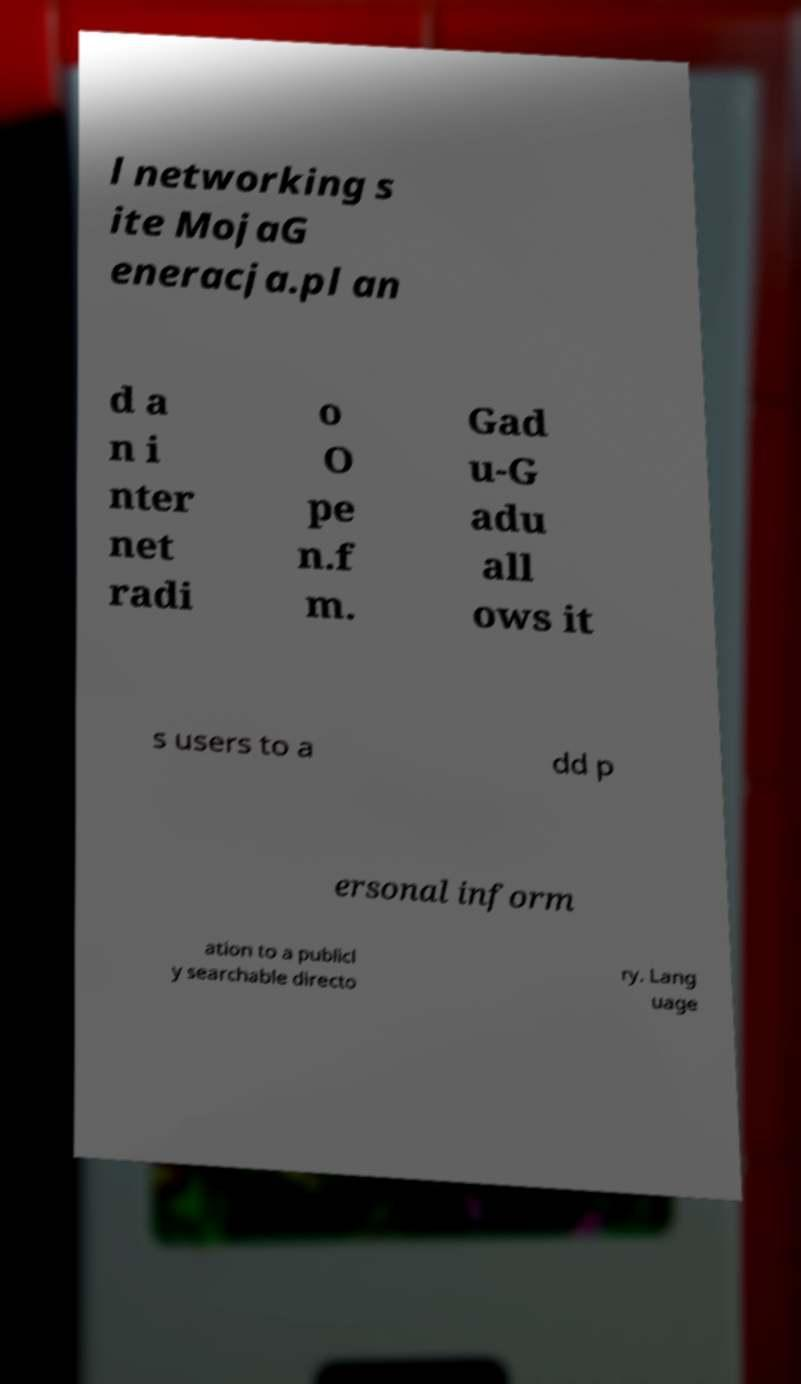Please identify and transcribe the text found in this image. l networking s ite MojaG eneracja.pl an d a n i nter net radi o O pe n.f m. Gad u-G adu all ows it s users to a dd p ersonal inform ation to a publicl y searchable directo ry. Lang uage 